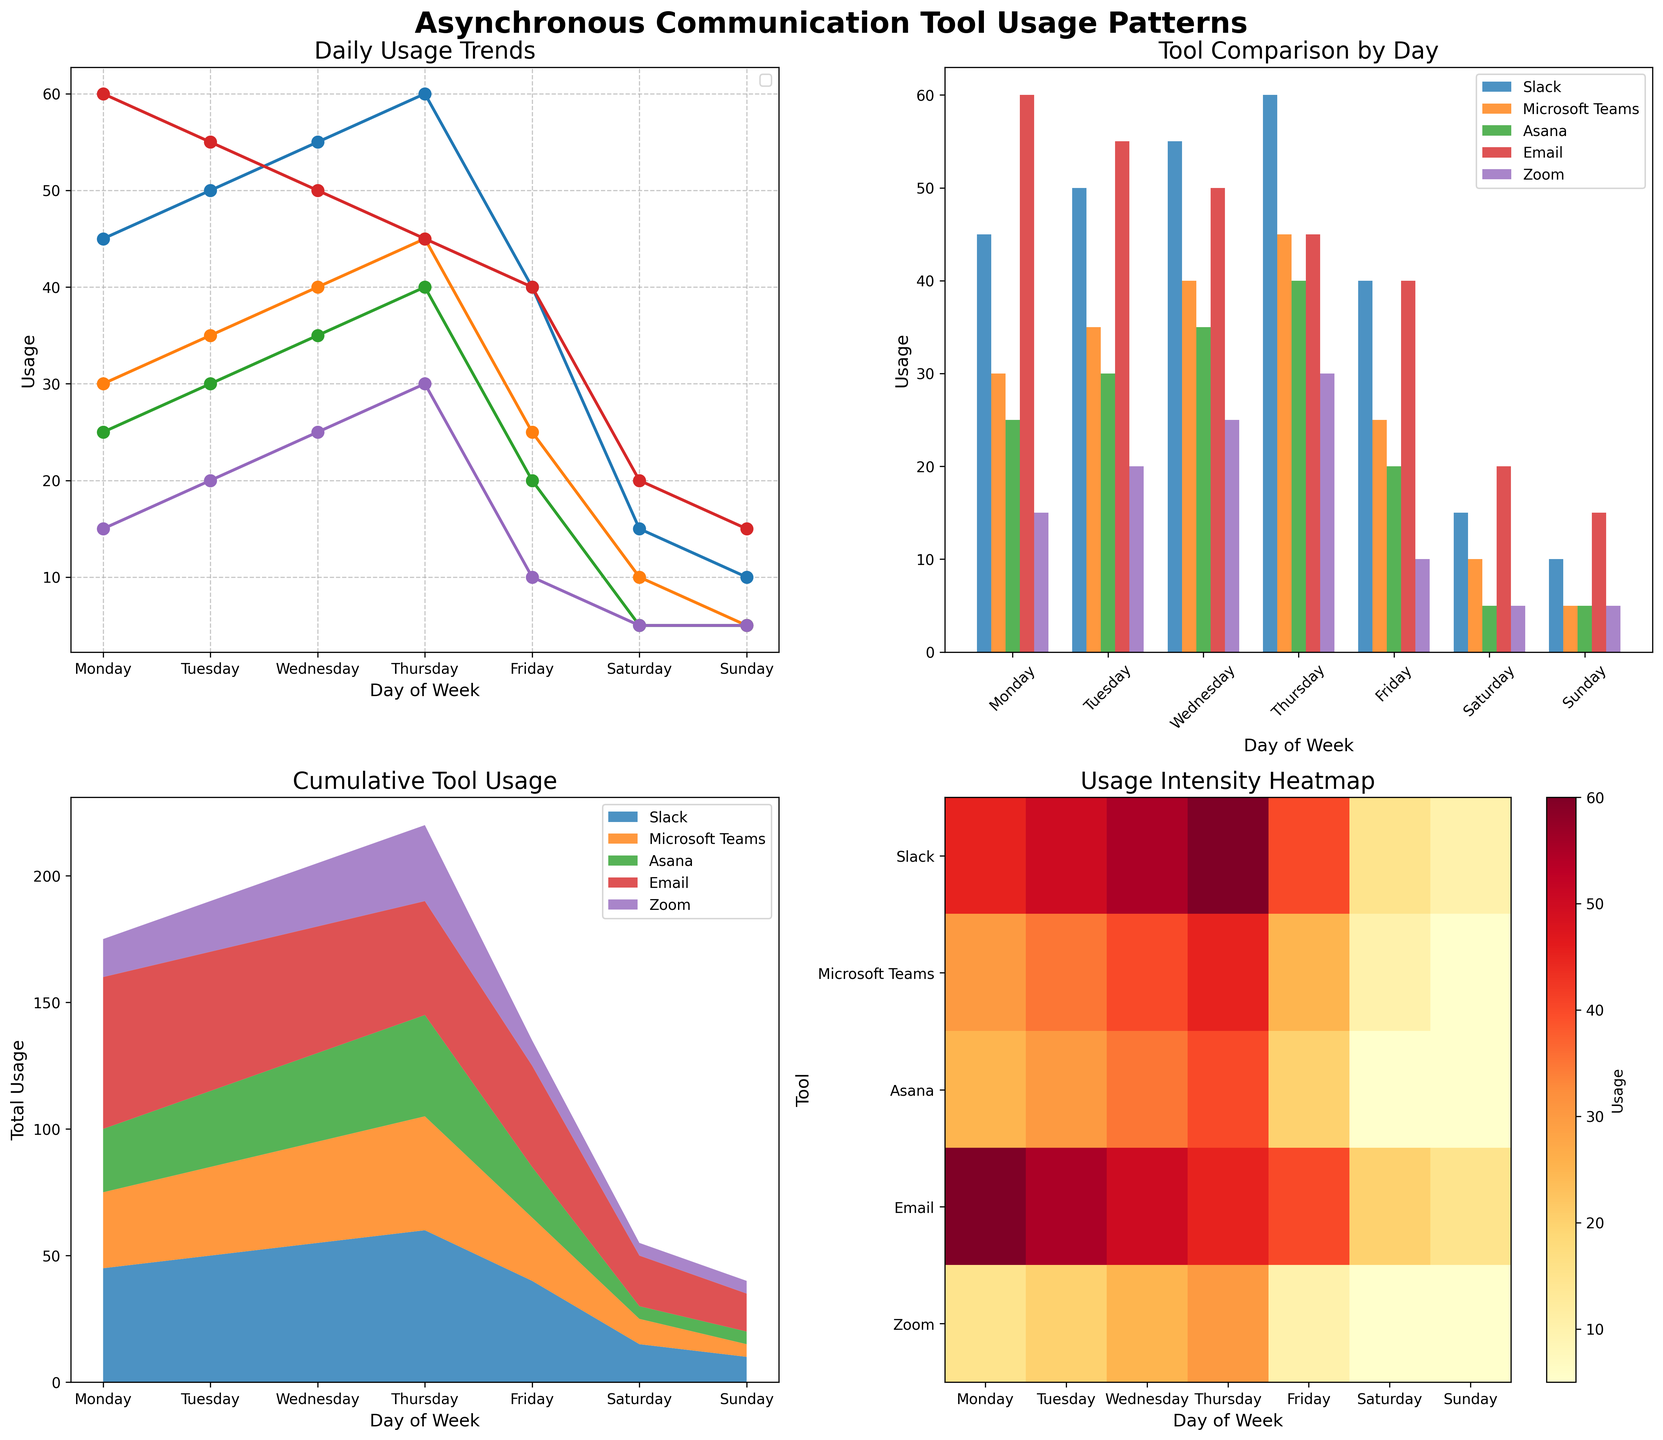what is the peak usage day for Slack? By inspecting the line plot in the top-left subplot, the highest point on the line representing Slack is on Thursday.
Answer: Thursday what day has the lowest email usage? From the line plot and the bar plot, the lowest usage of Email is on Sunday.
Answer: Sunday compare the interaction pattern of Zoom and Microsoft Teams: which has higher usage and when? By examining the line plot, Zoom shows consistently lower usage compared to Microsoft Teams through the week. However, on each day, Monday through Friday, Microsoft Teams clearly has higher usage than Zoom. On weekends, both have low usage, but Microsoft Teams still surpasses Zoom.
Answer: Microsoft Teams, Monday through Friday what’s the total usage of all communication tools on Wednesday? From the stacked area plot, we sum the values for Wednesday from Slack (55), Microsoft Teams (40), Asana (35), Email (50), and Zoom (25). Therefore, total usage = 55 + 40 + 35 + 50 + 25 = 205.
Answer: 205 which asynchronous communication tool has the most consistent usage pattern throughout the week? Analyzing the line plot, Slack shows a more or less consistent trend with gradual increases from Monday to Thursday and a considerable decrease towards the weekend. Other tools have more distinct peaks and valleys.
Answer: Slack on which day is Asana usage lowest? Referring to the line plot and the bar plot, Asana usage is at its lowest on Sunday.
Answer: Sunday during which day is the usage intensity highest overall? In the heatmap, the highest intensity color appears on Thursday across multiple tools like Slack, Microsoft Teams, Asana, Email, and Zoom, indicating the highest overall usage intensity on this day of the week.
Answer: Thursday which tool has a sharper drop in usage from Thursday to Friday? From the line plot, Slack shows a notable drop from 60 on Thursday to 40 on Friday, a difference of 20 units, which is sharper compared to Microsoft Teams, Asana, Email, and Zoom.
Answer: Slack on which weekday is Microsoft Teams used more than Email? Observing the line plot, Microsoft Teams is used more than Email from Tuesday to Thursday where each day shows higher values for Microsoft Teams compared to Email.
Answer: Tuesday, Wednesday, Thursday which tool stands out in the bar plot as having a notably lower usage on weekdays compared to others? Examining the bar plot, it's evident that Zoom has much lower usage compared to other tools during the weekdays.
Answer: Zoom 